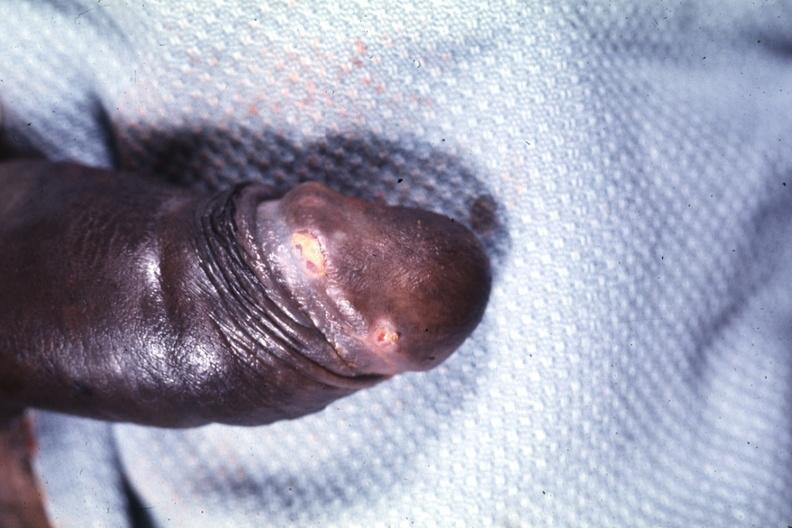s nipples present?
Answer the question using a single word or phrase. No 